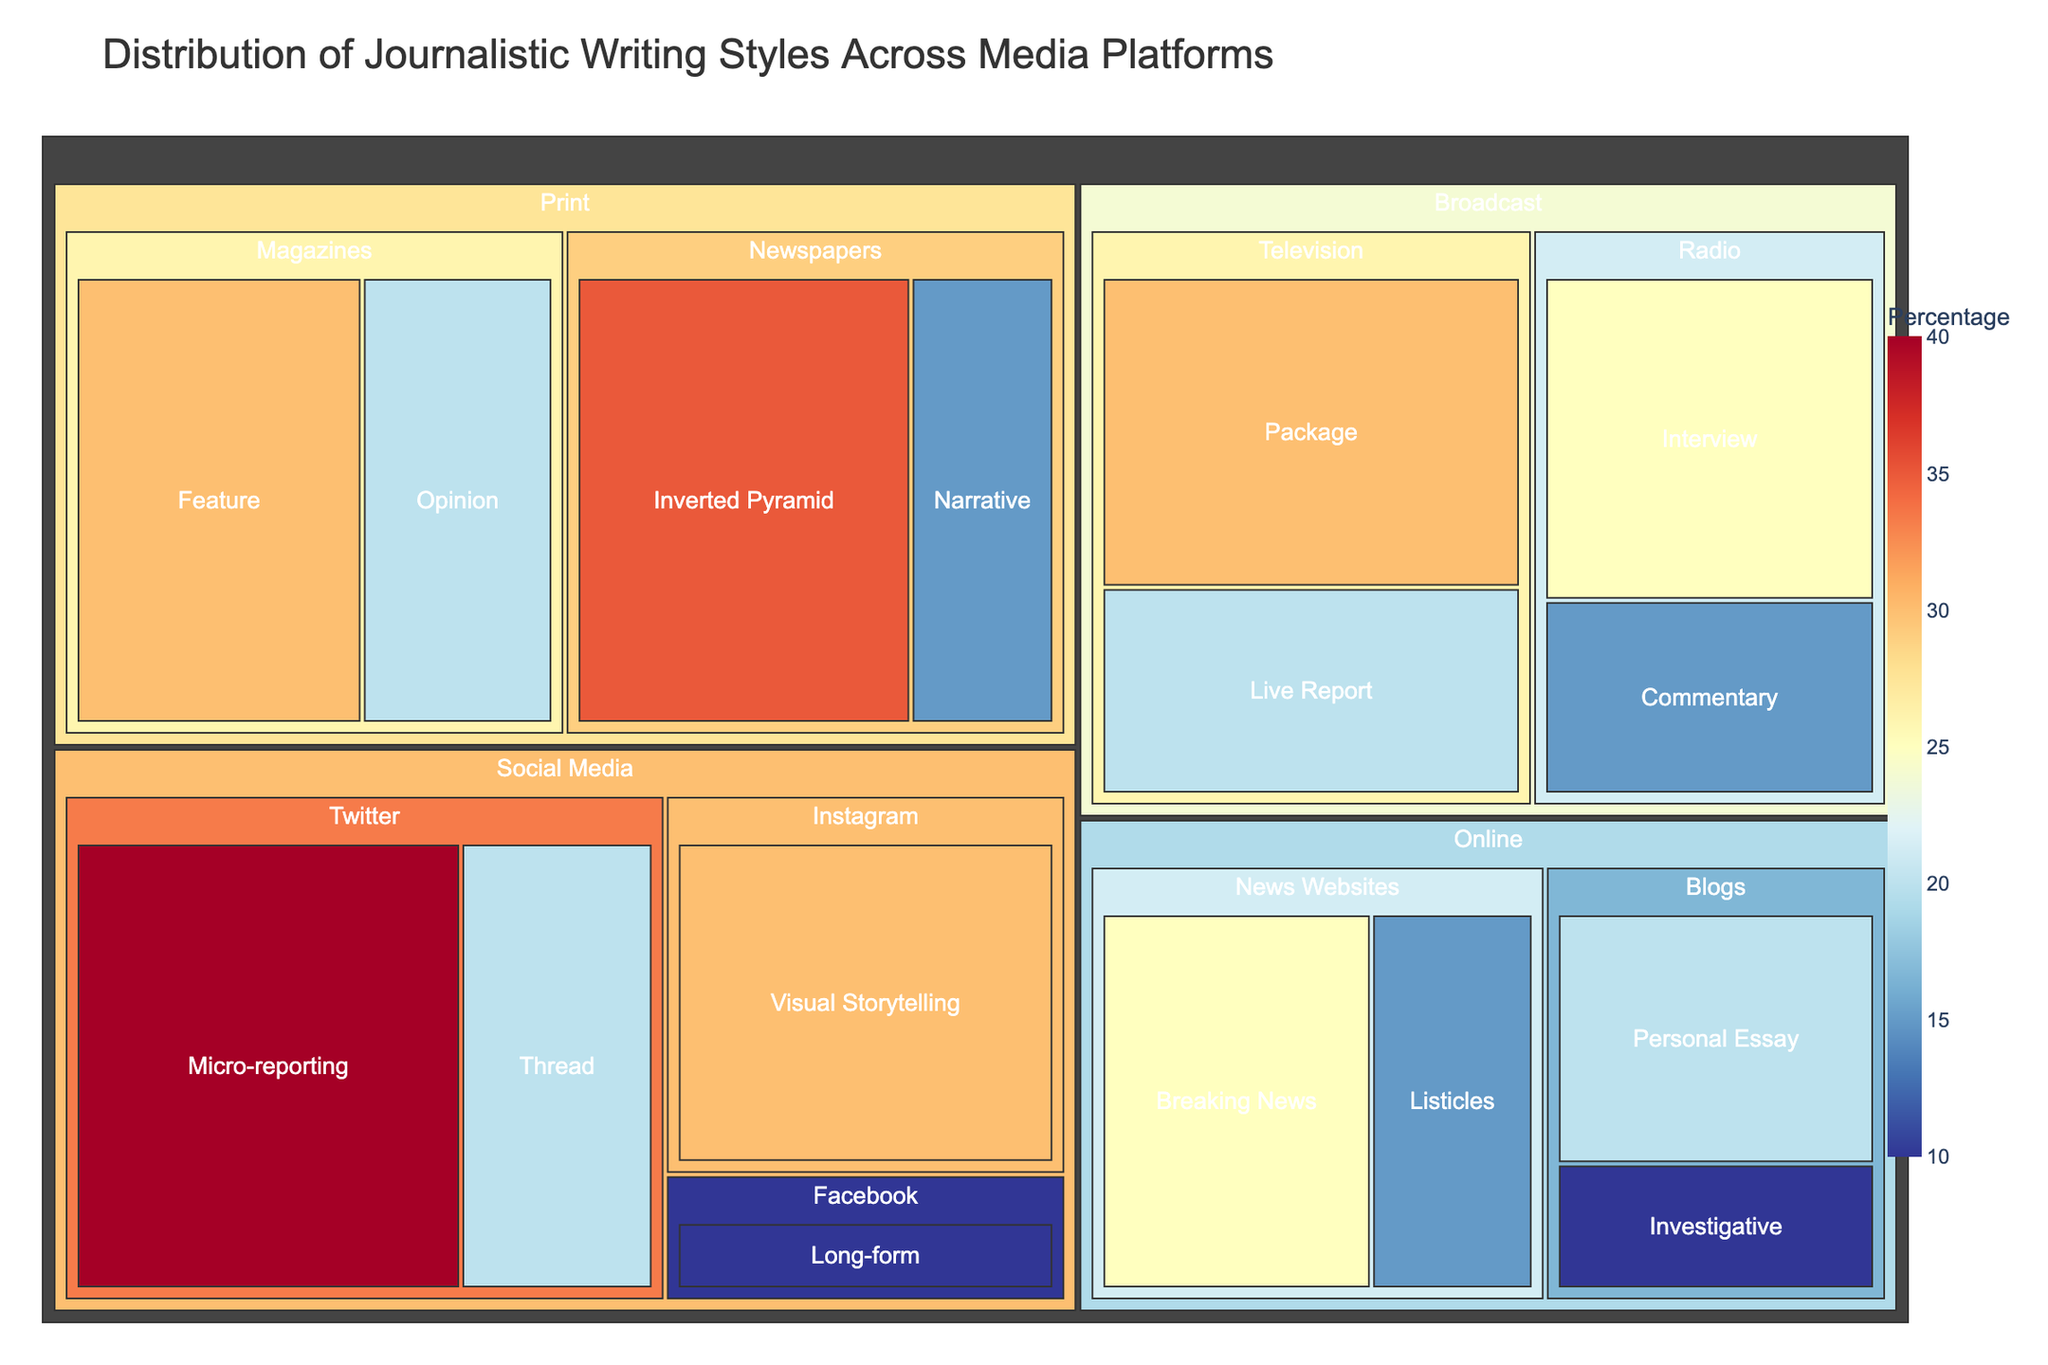what is the most common journalistic writing style on the Print platform? Look for the Print platform on the figure, then see which writing style has the highest percentage. The 'Inverted Pyramid' in Newspapers has the highest percentage of 35%.
Answer: Inverted Pyramid which platform has the highest use of Micro-reporting style? Check the various platforms for the style Micro-reporting. It is used exclusively on the Social Media platform, with a percentage of 40%.
Answer: Social Media what is the total percentage of Narrative and Opinion styles combined in Print media? Find the percentages for Narrative and Opinion in Print media, which are 15% and 20% respectively. Add these percentages together: 15% + 20% = 35%.
Answer: 35% which category in the Broadcast platform uses Package style, and what is its percentage? Look at the Broadcast platform, then locate the Package style under the Television category with a percentage of 30%.
Answer: Television, 30% which style in News Websites has a higher percentage, Breaking News or Listicles? Check the percentages of Breaking News and Listicles in News Websites. Breaking News has 25% and Listicles has 15%. Breaking News is higher.
Answer: Breaking News what is the combined percentage of all styles in the Blogs category on the Online platform? Locate the percentages for styles under Blogs category in Online platform: Personal Essay with 20% and Investigative with 10%. Add these percentages together: 20% + 10% = 30%.
Answer: 30% which style has the lowest percentage on the Social Media platform, and what is the percentage? Look at the various styles on the Social Media platform and find the lowest percentage. Long-form on Facebook has the lowest percentage, which is 10%.
Answer: Long-form, 10% is there any writing style that appears on multiple platforms? Scan through the list of styles under each platform. Each style appears to be unique to its respective platform based on the data provided.
Answer: No how does the distribution of journalism styles in Broadcast compare to that in Online? Compare the percentages in the Broadcast platform (Television and Radio) with those in the Online platform (News Websites and Blogs). Each style on these platforms has its own percentage and unique characteristics, so they must be examined side-by-side to identify detailed differences.
Answer: Different for each style 